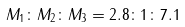Convert formula to latex. <formula><loc_0><loc_0><loc_500><loc_500>M _ { 1 } \colon M _ { 2 } \colon M _ { 3 } = 2 . 8 \colon 1 \colon 7 . 1</formula> 